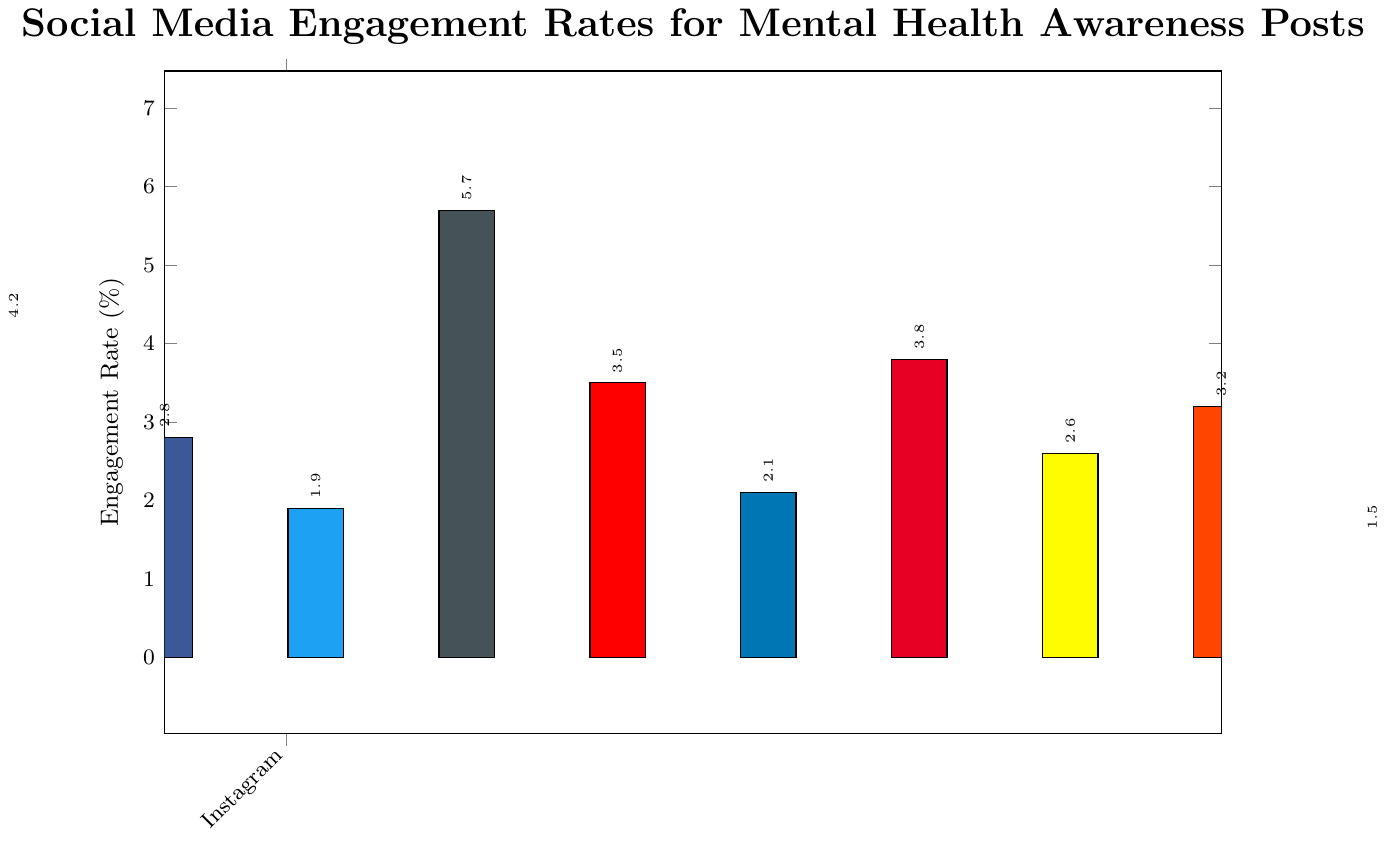What is the engagement rate for Instagram? The bar for Instagram reaches up to 4.2% on the vertical axis.
Answer: 4.2% Which platform has the highest engagement rate? The highest bar on the chart corresponds to TikTok with an engagement rate of 5.7%.
Answer: TikTok Which two platforms have the closest engagement rates? Looking at the bars, YouTube and Pinterest have closely matched heights, with engagement rates of 3.5% and 3.8%, respectively.
Answer: YouTube and Pinterest Calculate the average engagement rate across all platforms. Sum the engagement rates: (4.2 + 2.8 + 1.9 + 5.7 + 3.5 + 2.1 + 3.8 + 2.6 + 3.2 + 1.5) = 31.3%, then divide by the number of platforms, which is 10. The average is 31.3 / 10 = 3.13%
Answer: 3.13% Which platform has a lower engagement rate, Facebook or LinkedIn, and by how much? Facebook has a 2.8% engagement rate, while LinkedIn has 2.1%. The difference is 2.8 - 2.1 = 0.7%.
Answer: LinkedIn, by 0.7% Order the platforms from the lowest to the highest engagement rate. Observing the heights of the bars, the order is: Tumblr (1.5%), Twitter (1.9%), LinkedIn (2.1%), Snapchat (2.6%), Facebook (2.8%), Reddit (3.2%), YouTube (3.5%), Pinterest (3.8%), Instagram (4.2%), TikTok (5.7%).
Answer: Tumblr, Twitter, LinkedIn, Snapchat, Facebook, Reddit, YouTube, Pinterest, Instagram, TikTok What is the difference between the highest and lowest engagement rates? The highest engagement rate is 5.7% (TikTok) and the lowest is 1.5% (Tumblr). The difference is 5.7 - 1.5 = 4.2%.
Answer: 4.2% If you combine engagement rates for Instagram, Facebook, and Twitter, what would be the total? Add the engagement rates: 4.2% (Instagram) + 2.8% (Facebook) + 1.9% (Twitter) = 8.9%.
Answer: 8.9% 